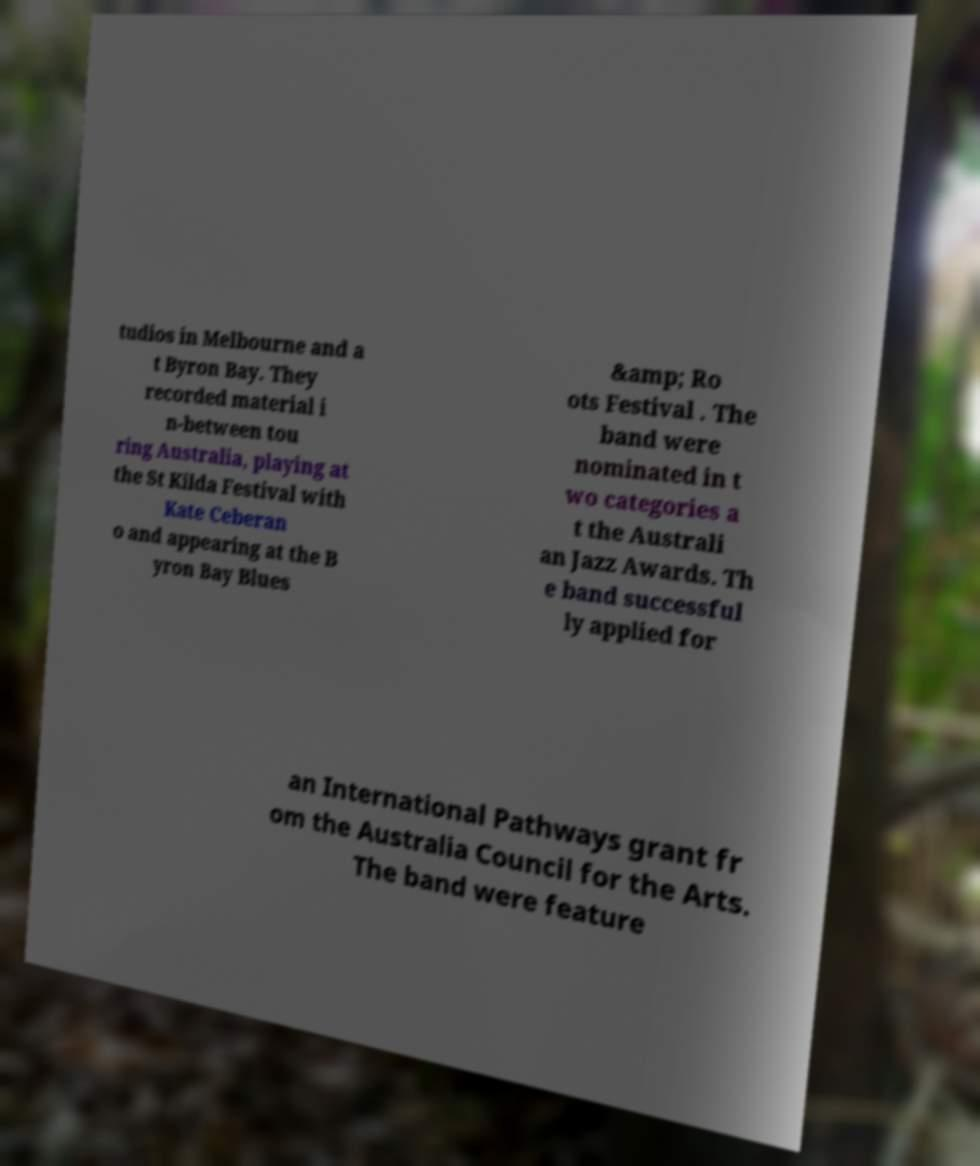Can you read and provide the text displayed in the image?This photo seems to have some interesting text. Can you extract and type it out for me? tudios in Melbourne and a t Byron Bay. They recorded material i n-between tou ring Australia, playing at the St Kilda Festival with Kate Ceberan o and appearing at the B yron Bay Blues &amp; Ro ots Festival . The band were nominated in t wo categories a t the Australi an Jazz Awards. Th e band successful ly applied for an International Pathways grant fr om the Australia Council for the Arts. The band were feature 